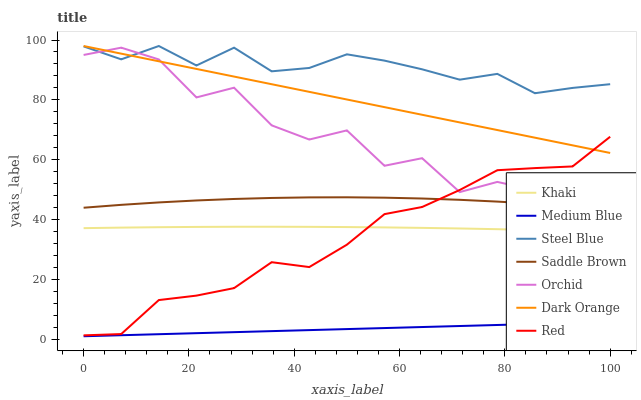Does Medium Blue have the minimum area under the curve?
Answer yes or no. Yes. Does Steel Blue have the maximum area under the curve?
Answer yes or no. Yes. Does Khaki have the minimum area under the curve?
Answer yes or no. No. Does Khaki have the maximum area under the curve?
Answer yes or no. No. Is Medium Blue the smoothest?
Answer yes or no. Yes. Is Orchid the roughest?
Answer yes or no. Yes. Is Khaki the smoothest?
Answer yes or no. No. Is Khaki the roughest?
Answer yes or no. No. Does Medium Blue have the lowest value?
Answer yes or no. Yes. Does Khaki have the lowest value?
Answer yes or no. No. Does Steel Blue have the highest value?
Answer yes or no. Yes. Does Khaki have the highest value?
Answer yes or no. No. Is Medium Blue less than Orchid?
Answer yes or no. Yes. Is Steel Blue greater than Red?
Answer yes or no. Yes. Does Red intersect Dark Orange?
Answer yes or no. Yes. Is Red less than Dark Orange?
Answer yes or no. No. Is Red greater than Dark Orange?
Answer yes or no. No. Does Medium Blue intersect Orchid?
Answer yes or no. No. 